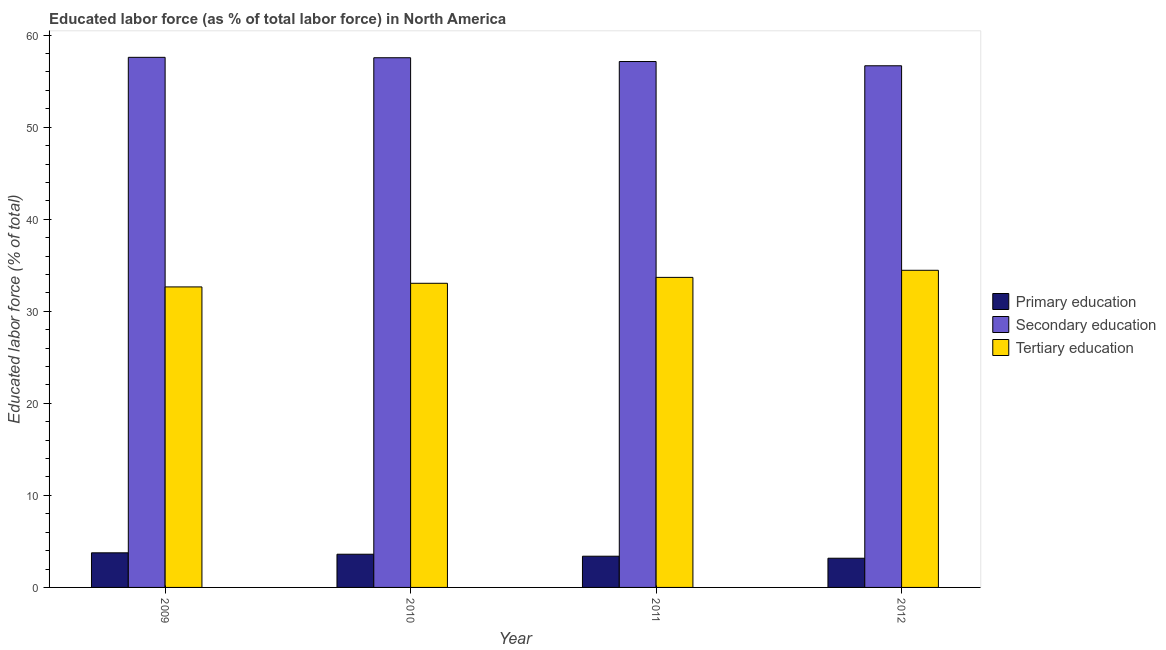How many different coloured bars are there?
Keep it short and to the point. 3. How many groups of bars are there?
Provide a short and direct response. 4. Are the number of bars on each tick of the X-axis equal?
Offer a very short reply. Yes. How many bars are there on the 4th tick from the left?
Give a very brief answer. 3. How many bars are there on the 3rd tick from the right?
Make the answer very short. 3. What is the percentage of labor force who received secondary education in 2012?
Offer a terse response. 56.67. Across all years, what is the maximum percentage of labor force who received primary education?
Offer a terse response. 3.76. Across all years, what is the minimum percentage of labor force who received primary education?
Offer a very short reply. 3.17. What is the total percentage of labor force who received secondary education in the graph?
Give a very brief answer. 228.95. What is the difference between the percentage of labor force who received secondary education in 2009 and that in 2012?
Provide a succinct answer. 0.92. What is the difference between the percentage of labor force who received primary education in 2011 and the percentage of labor force who received secondary education in 2009?
Offer a very short reply. -0.37. What is the average percentage of labor force who received primary education per year?
Your response must be concise. 3.48. In the year 2011, what is the difference between the percentage of labor force who received tertiary education and percentage of labor force who received secondary education?
Provide a succinct answer. 0. What is the ratio of the percentage of labor force who received tertiary education in 2009 to that in 2011?
Keep it short and to the point. 0.97. Is the percentage of labor force who received tertiary education in 2009 less than that in 2012?
Provide a succinct answer. Yes. Is the difference between the percentage of labor force who received tertiary education in 2011 and 2012 greater than the difference between the percentage of labor force who received secondary education in 2011 and 2012?
Provide a succinct answer. No. What is the difference between the highest and the second highest percentage of labor force who received primary education?
Offer a terse response. 0.15. What is the difference between the highest and the lowest percentage of labor force who received primary education?
Provide a succinct answer. 0.59. In how many years, is the percentage of labor force who received tertiary education greater than the average percentage of labor force who received tertiary education taken over all years?
Offer a terse response. 2. Is the sum of the percentage of labor force who received primary education in 2010 and 2012 greater than the maximum percentage of labor force who received tertiary education across all years?
Ensure brevity in your answer.  Yes. What does the 2nd bar from the left in 2011 represents?
Ensure brevity in your answer.  Secondary education. What does the 1st bar from the right in 2012 represents?
Your answer should be compact. Tertiary education. Are all the bars in the graph horizontal?
Make the answer very short. No. Where does the legend appear in the graph?
Give a very brief answer. Center right. How are the legend labels stacked?
Offer a terse response. Vertical. What is the title of the graph?
Offer a very short reply. Educated labor force (as % of total labor force) in North America. Does "Gaseous fuel" appear as one of the legend labels in the graph?
Your response must be concise. No. What is the label or title of the Y-axis?
Provide a short and direct response. Educated labor force (% of total). What is the Educated labor force (% of total) in Primary education in 2009?
Your response must be concise. 3.76. What is the Educated labor force (% of total) of Secondary education in 2009?
Keep it short and to the point. 57.59. What is the Educated labor force (% of total) in Tertiary education in 2009?
Your answer should be compact. 32.65. What is the Educated labor force (% of total) in Primary education in 2010?
Your response must be concise. 3.61. What is the Educated labor force (% of total) of Secondary education in 2010?
Your answer should be very brief. 57.55. What is the Educated labor force (% of total) of Tertiary education in 2010?
Keep it short and to the point. 33.04. What is the Educated labor force (% of total) of Primary education in 2011?
Ensure brevity in your answer.  3.39. What is the Educated labor force (% of total) of Secondary education in 2011?
Your answer should be compact. 57.14. What is the Educated labor force (% of total) in Tertiary education in 2011?
Provide a short and direct response. 33.68. What is the Educated labor force (% of total) of Primary education in 2012?
Give a very brief answer. 3.17. What is the Educated labor force (% of total) in Secondary education in 2012?
Your response must be concise. 56.67. What is the Educated labor force (% of total) of Tertiary education in 2012?
Give a very brief answer. 34.45. Across all years, what is the maximum Educated labor force (% of total) in Primary education?
Provide a succinct answer. 3.76. Across all years, what is the maximum Educated labor force (% of total) in Secondary education?
Make the answer very short. 57.59. Across all years, what is the maximum Educated labor force (% of total) in Tertiary education?
Ensure brevity in your answer.  34.45. Across all years, what is the minimum Educated labor force (% of total) in Primary education?
Provide a succinct answer. 3.17. Across all years, what is the minimum Educated labor force (% of total) in Secondary education?
Offer a terse response. 56.67. Across all years, what is the minimum Educated labor force (% of total) of Tertiary education?
Offer a very short reply. 32.65. What is the total Educated labor force (% of total) of Primary education in the graph?
Your answer should be compact. 13.93. What is the total Educated labor force (% of total) in Secondary education in the graph?
Offer a terse response. 228.95. What is the total Educated labor force (% of total) of Tertiary education in the graph?
Provide a short and direct response. 133.83. What is the difference between the Educated labor force (% of total) of Primary education in 2009 and that in 2010?
Offer a terse response. 0.15. What is the difference between the Educated labor force (% of total) of Secondary education in 2009 and that in 2010?
Give a very brief answer. 0.05. What is the difference between the Educated labor force (% of total) in Tertiary education in 2009 and that in 2010?
Your response must be concise. -0.39. What is the difference between the Educated labor force (% of total) of Primary education in 2009 and that in 2011?
Make the answer very short. 0.37. What is the difference between the Educated labor force (% of total) of Secondary education in 2009 and that in 2011?
Your answer should be very brief. 0.46. What is the difference between the Educated labor force (% of total) in Tertiary education in 2009 and that in 2011?
Ensure brevity in your answer.  -1.04. What is the difference between the Educated labor force (% of total) in Primary education in 2009 and that in 2012?
Provide a short and direct response. 0.59. What is the difference between the Educated labor force (% of total) of Tertiary education in 2009 and that in 2012?
Offer a very short reply. -1.81. What is the difference between the Educated labor force (% of total) of Primary education in 2010 and that in 2011?
Keep it short and to the point. 0.22. What is the difference between the Educated labor force (% of total) of Secondary education in 2010 and that in 2011?
Your answer should be compact. 0.41. What is the difference between the Educated labor force (% of total) in Tertiary education in 2010 and that in 2011?
Keep it short and to the point. -0.64. What is the difference between the Educated labor force (% of total) of Primary education in 2010 and that in 2012?
Provide a short and direct response. 0.44. What is the difference between the Educated labor force (% of total) of Secondary education in 2010 and that in 2012?
Provide a succinct answer. 0.87. What is the difference between the Educated labor force (% of total) in Tertiary education in 2010 and that in 2012?
Ensure brevity in your answer.  -1.41. What is the difference between the Educated labor force (% of total) of Primary education in 2011 and that in 2012?
Offer a very short reply. 0.22. What is the difference between the Educated labor force (% of total) in Secondary education in 2011 and that in 2012?
Offer a very short reply. 0.46. What is the difference between the Educated labor force (% of total) of Tertiary education in 2011 and that in 2012?
Your response must be concise. -0.77. What is the difference between the Educated labor force (% of total) of Primary education in 2009 and the Educated labor force (% of total) of Secondary education in 2010?
Provide a succinct answer. -53.79. What is the difference between the Educated labor force (% of total) of Primary education in 2009 and the Educated labor force (% of total) of Tertiary education in 2010?
Offer a very short reply. -29.28. What is the difference between the Educated labor force (% of total) in Secondary education in 2009 and the Educated labor force (% of total) in Tertiary education in 2010?
Give a very brief answer. 24.55. What is the difference between the Educated labor force (% of total) of Primary education in 2009 and the Educated labor force (% of total) of Secondary education in 2011?
Your answer should be very brief. -53.38. What is the difference between the Educated labor force (% of total) in Primary education in 2009 and the Educated labor force (% of total) in Tertiary education in 2011?
Offer a very short reply. -29.93. What is the difference between the Educated labor force (% of total) in Secondary education in 2009 and the Educated labor force (% of total) in Tertiary education in 2011?
Offer a very short reply. 23.91. What is the difference between the Educated labor force (% of total) of Primary education in 2009 and the Educated labor force (% of total) of Secondary education in 2012?
Ensure brevity in your answer.  -52.92. What is the difference between the Educated labor force (% of total) of Primary education in 2009 and the Educated labor force (% of total) of Tertiary education in 2012?
Ensure brevity in your answer.  -30.7. What is the difference between the Educated labor force (% of total) in Secondary education in 2009 and the Educated labor force (% of total) in Tertiary education in 2012?
Ensure brevity in your answer.  23.14. What is the difference between the Educated labor force (% of total) of Primary education in 2010 and the Educated labor force (% of total) of Secondary education in 2011?
Offer a very short reply. -53.53. What is the difference between the Educated labor force (% of total) of Primary education in 2010 and the Educated labor force (% of total) of Tertiary education in 2011?
Offer a terse response. -30.08. What is the difference between the Educated labor force (% of total) of Secondary education in 2010 and the Educated labor force (% of total) of Tertiary education in 2011?
Offer a terse response. 23.86. What is the difference between the Educated labor force (% of total) in Primary education in 2010 and the Educated labor force (% of total) in Secondary education in 2012?
Make the answer very short. -53.07. What is the difference between the Educated labor force (% of total) in Primary education in 2010 and the Educated labor force (% of total) in Tertiary education in 2012?
Provide a succinct answer. -30.85. What is the difference between the Educated labor force (% of total) in Secondary education in 2010 and the Educated labor force (% of total) in Tertiary education in 2012?
Provide a short and direct response. 23.09. What is the difference between the Educated labor force (% of total) of Primary education in 2011 and the Educated labor force (% of total) of Secondary education in 2012?
Your answer should be very brief. -53.28. What is the difference between the Educated labor force (% of total) in Primary education in 2011 and the Educated labor force (% of total) in Tertiary education in 2012?
Give a very brief answer. -31.06. What is the difference between the Educated labor force (% of total) of Secondary education in 2011 and the Educated labor force (% of total) of Tertiary education in 2012?
Offer a terse response. 22.68. What is the average Educated labor force (% of total) in Primary education per year?
Provide a short and direct response. 3.48. What is the average Educated labor force (% of total) of Secondary education per year?
Offer a very short reply. 57.24. What is the average Educated labor force (% of total) in Tertiary education per year?
Your answer should be compact. 33.46. In the year 2009, what is the difference between the Educated labor force (% of total) in Primary education and Educated labor force (% of total) in Secondary education?
Ensure brevity in your answer.  -53.83. In the year 2009, what is the difference between the Educated labor force (% of total) in Primary education and Educated labor force (% of total) in Tertiary education?
Make the answer very short. -28.89. In the year 2009, what is the difference between the Educated labor force (% of total) of Secondary education and Educated labor force (% of total) of Tertiary education?
Provide a short and direct response. 24.94. In the year 2010, what is the difference between the Educated labor force (% of total) of Primary education and Educated labor force (% of total) of Secondary education?
Your response must be concise. -53.94. In the year 2010, what is the difference between the Educated labor force (% of total) of Primary education and Educated labor force (% of total) of Tertiary education?
Provide a short and direct response. -29.44. In the year 2010, what is the difference between the Educated labor force (% of total) of Secondary education and Educated labor force (% of total) of Tertiary education?
Give a very brief answer. 24.5. In the year 2011, what is the difference between the Educated labor force (% of total) of Primary education and Educated labor force (% of total) of Secondary education?
Provide a succinct answer. -53.74. In the year 2011, what is the difference between the Educated labor force (% of total) of Primary education and Educated labor force (% of total) of Tertiary education?
Your answer should be compact. -30.29. In the year 2011, what is the difference between the Educated labor force (% of total) in Secondary education and Educated labor force (% of total) in Tertiary education?
Keep it short and to the point. 23.45. In the year 2012, what is the difference between the Educated labor force (% of total) in Primary education and Educated labor force (% of total) in Secondary education?
Your answer should be very brief. -53.5. In the year 2012, what is the difference between the Educated labor force (% of total) in Primary education and Educated labor force (% of total) in Tertiary education?
Offer a very short reply. -31.28. In the year 2012, what is the difference between the Educated labor force (% of total) of Secondary education and Educated labor force (% of total) of Tertiary education?
Offer a very short reply. 22.22. What is the ratio of the Educated labor force (% of total) of Primary education in 2009 to that in 2010?
Your answer should be compact. 1.04. What is the ratio of the Educated labor force (% of total) of Secondary education in 2009 to that in 2010?
Provide a short and direct response. 1. What is the ratio of the Educated labor force (% of total) of Tertiary education in 2009 to that in 2010?
Provide a short and direct response. 0.99. What is the ratio of the Educated labor force (% of total) in Primary education in 2009 to that in 2011?
Your answer should be very brief. 1.11. What is the ratio of the Educated labor force (% of total) of Secondary education in 2009 to that in 2011?
Give a very brief answer. 1.01. What is the ratio of the Educated labor force (% of total) of Tertiary education in 2009 to that in 2011?
Your answer should be very brief. 0.97. What is the ratio of the Educated labor force (% of total) of Primary education in 2009 to that in 2012?
Provide a short and direct response. 1.19. What is the ratio of the Educated labor force (% of total) in Secondary education in 2009 to that in 2012?
Offer a terse response. 1.02. What is the ratio of the Educated labor force (% of total) in Tertiary education in 2009 to that in 2012?
Give a very brief answer. 0.95. What is the ratio of the Educated labor force (% of total) in Primary education in 2010 to that in 2011?
Keep it short and to the point. 1.06. What is the ratio of the Educated labor force (% of total) in Tertiary education in 2010 to that in 2011?
Provide a succinct answer. 0.98. What is the ratio of the Educated labor force (% of total) in Primary education in 2010 to that in 2012?
Make the answer very short. 1.14. What is the ratio of the Educated labor force (% of total) of Secondary education in 2010 to that in 2012?
Keep it short and to the point. 1.02. What is the ratio of the Educated labor force (% of total) of Primary education in 2011 to that in 2012?
Make the answer very short. 1.07. What is the ratio of the Educated labor force (% of total) in Secondary education in 2011 to that in 2012?
Provide a succinct answer. 1.01. What is the ratio of the Educated labor force (% of total) in Tertiary education in 2011 to that in 2012?
Offer a very short reply. 0.98. What is the difference between the highest and the second highest Educated labor force (% of total) of Primary education?
Your answer should be very brief. 0.15. What is the difference between the highest and the second highest Educated labor force (% of total) in Secondary education?
Offer a terse response. 0.05. What is the difference between the highest and the second highest Educated labor force (% of total) of Tertiary education?
Ensure brevity in your answer.  0.77. What is the difference between the highest and the lowest Educated labor force (% of total) of Primary education?
Your answer should be compact. 0.59. What is the difference between the highest and the lowest Educated labor force (% of total) of Secondary education?
Keep it short and to the point. 0.92. What is the difference between the highest and the lowest Educated labor force (% of total) in Tertiary education?
Your answer should be compact. 1.81. 